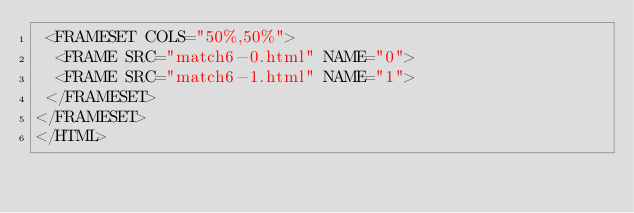Convert code to text. <code><loc_0><loc_0><loc_500><loc_500><_HTML_> <FRAMESET COLS="50%,50%">
  <FRAME SRC="match6-0.html" NAME="0">
  <FRAME SRC="match6-1.html" NAME="1">
 </FRAMESET>
</FRAMESET>
</HTML>
</code> 